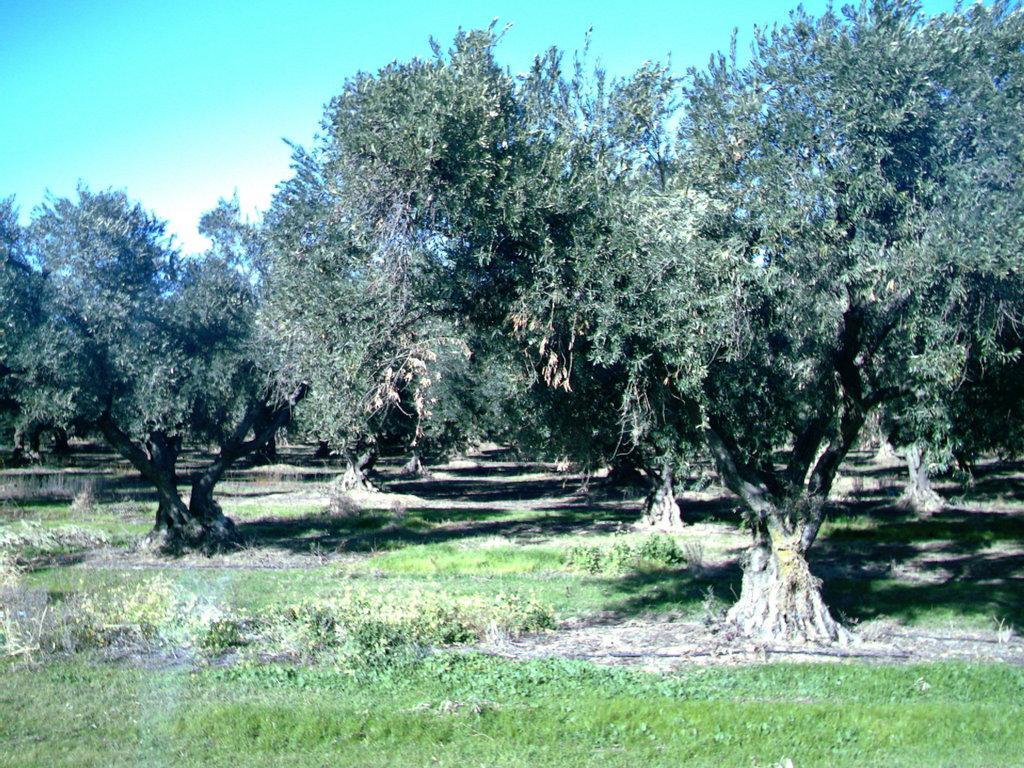Describe this image in one or two sentences. This image consists of many trees. At the bottom, there is green grass on the ground. At the top, there is the sky. 